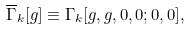Convert formula to latex. <formula><loc_0><loc_0><loc_500><loc_500>\overline { \Gamma } _ { k } [ g ] \equiv \Gamma _ { k } [ g , g , 0 , 0 ; 0 , 0 ] ,</formula> 